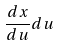<formula> <loc_0><loc_0><loc_500><loc_500>\frac { d x } { d u } d u</formula> 